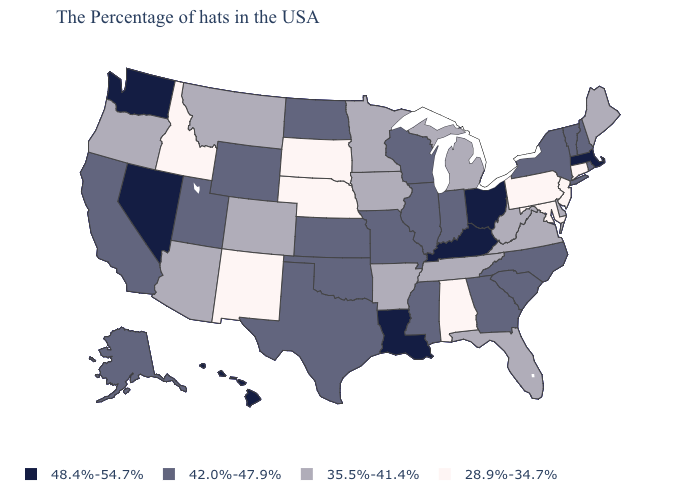Which states have the lowest value in the USA?
Write a very short answer. Connecticut, New Jersey, Maryland, Pennsylvania, Alabama, Nebraska, South Dakota, New Mexico, Idaho. What is the value of North Carolina?
Be succinct. 42.0%-47.9%. Which states have the lowest value in the USA?
Give a very brief answer. Connecticut, New Jersey, Maryland, Pennsylvania, Alabama, Nebraska, South Dakota, New Mexico, Idaho. How many symbols are there in the legend?
Quick response, please. 4. Name the states that have a value in the range 42.0%-47.9%?
Give a very brief answer. Rhode Island, New Hampshire, Vermont, New York, North Carolina, South Carolina, Georgia, Indiana, Wisconsin, Illinois, Mississippi, Missouri, Kansas, Oklahoma, Texas, North Dakota, Wyoming, Utah, California, Alaska. What is the highest value in the USA?
Keep it brief. 48.4%-54.7%. Which states hav the highest value in the MidWest?
Short answer required. Ohio. Name the states that have a value in the range 48.4%-54.7%?
Concise answer only. Massachusetts, Ohio, Kentucky, Louisiana, Nevada, Washington, Hawaii. Which states have the lowest value in the USA?
Answer briefly. Connecticut, New Jersey, Maryland, Pennsylvania, Alabama, Nebraska, South Dakota, New Mexico, Idaho. Does Kentucky have a lower value than Oklahoma?
Short answer required. No. What is the highest value in the USA?
Short answer required. 48.4%-54.7%. Which states have the lowest value in the Northeast?
Answer briefly. Connecticut, New Jersey, Pennsylvania. Does Massachusetts have the same value as Nevada?
Be succinct. Yes. Name the states that have a value in the range 42.0%-47.9%?
Short answer required. Rhode Island, New Hampshire, Vermont, New York, North Carolina, South Carolina, Georgia, Indiana, Wisconsin, Illinois, Mississippi, Missouri, Kansas, Oklahoma, Texas, North Dakota, Wyoming, Utah, California, Alaska. What is the value of Oklahoma?
Give a very brief answer. 42.0%-47.9%. 